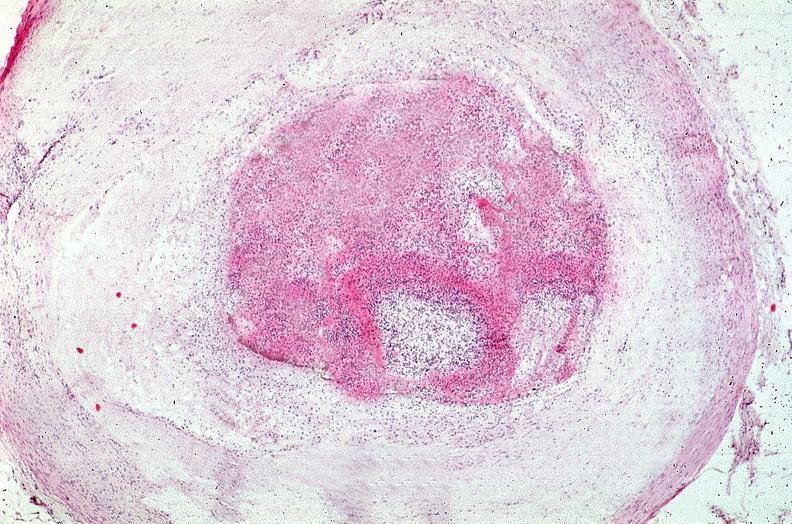does this image show coronary artery with atherosclerosis and thrombotic occlusion?
Answer the question using a single word or phrase. Yes 